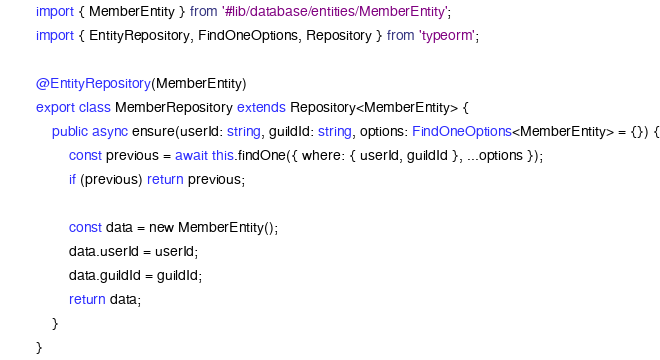<code> <loc_0><loc_0><loc_500><loc_500><_TypeScript_>import { MemberEntity } from '#lib/database/entities/MemberEntity';
import { EntityRepository, FindOneOptions, Repository } from 'typeorm';

@EntityRepository(MemberEntity)
export class MemberRepository extends Repository<MemberEntity> {
	public async ensure(userId: string, guildId: string, options: FindOneOptions<MemberEntity> = {}) {
		const previous = await this.findOne({ where: { userId, guildId }, ...options });
		if (previous) return previous;

		const data = new MemberEntity();
		data.userId = userId;
		data.guildId = guildId;
		return data;
	}
}
</code> 